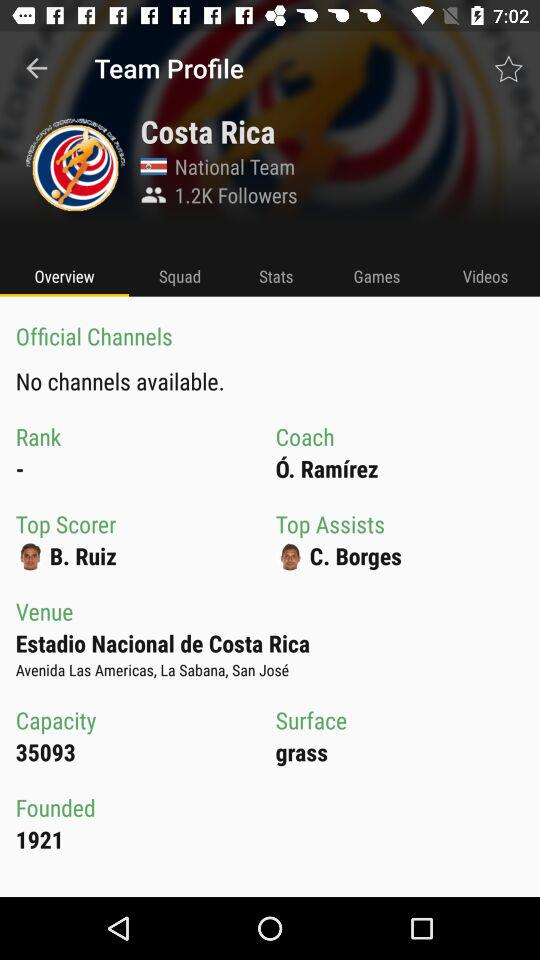Is there any channel available? There are no channels available. 